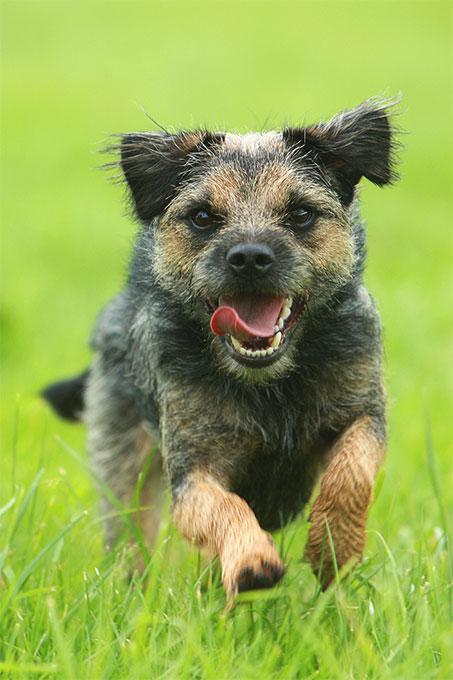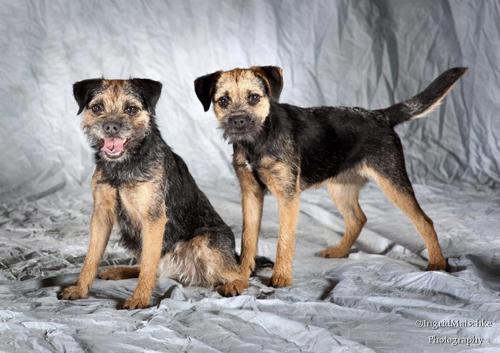The first image is the image on the left, the second image is the image on the right. Evaluate the accuracy of this statement regarding the images: "The dog in the image on the left is on a green grassy surface.". Is it true? Answer yes or no. Yes. The first image is the image on the left, the second image is the image on the right. Analyze the images presented: Is the assertion "An image includes a standing dog with its body turned leftward and its tail extended outward." valid? Answer yes or no. Yes. 